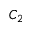Convert formula to latex. <formula><loc_0><loc_0><loc_500><loc_500>C _ { 2 }</formula> 